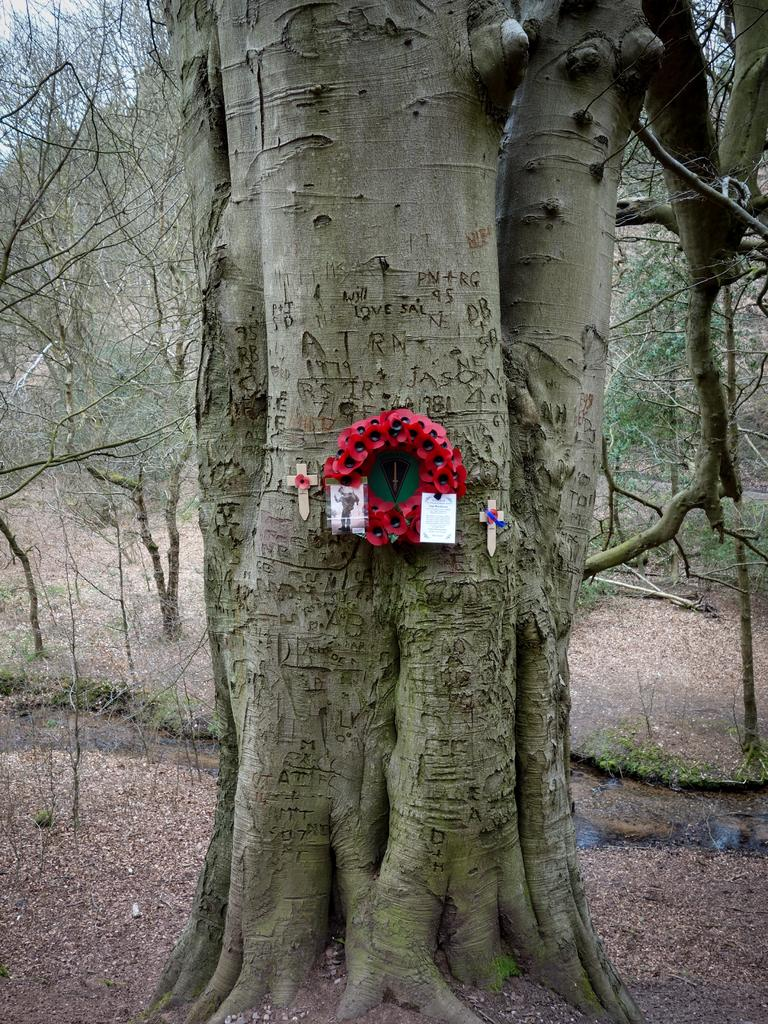What can be seen in the foreground of the image? In the foreground of the image, there are dry leaves, the trunk of a tree, and other objects. What is the primary focus of the foreground? The primary focus of the foreground is the trunk of a tree. What can be seen in the background of the image? In the background of the image, there are trees, dry leaves, and the sky. How does the background contribute to the overall image? The background provides context and a sense of the natural environment surrounding the tree trunk. What invention is being demonstrated in the image? There is no invention being demonstrated in the image; it primarily features a tree trunk and its surrounding environment. What type of yarn is being used to create the dry leaves in the image? There is no yarn present in the image; the dry leaves are actual leaves in a natural setting. 